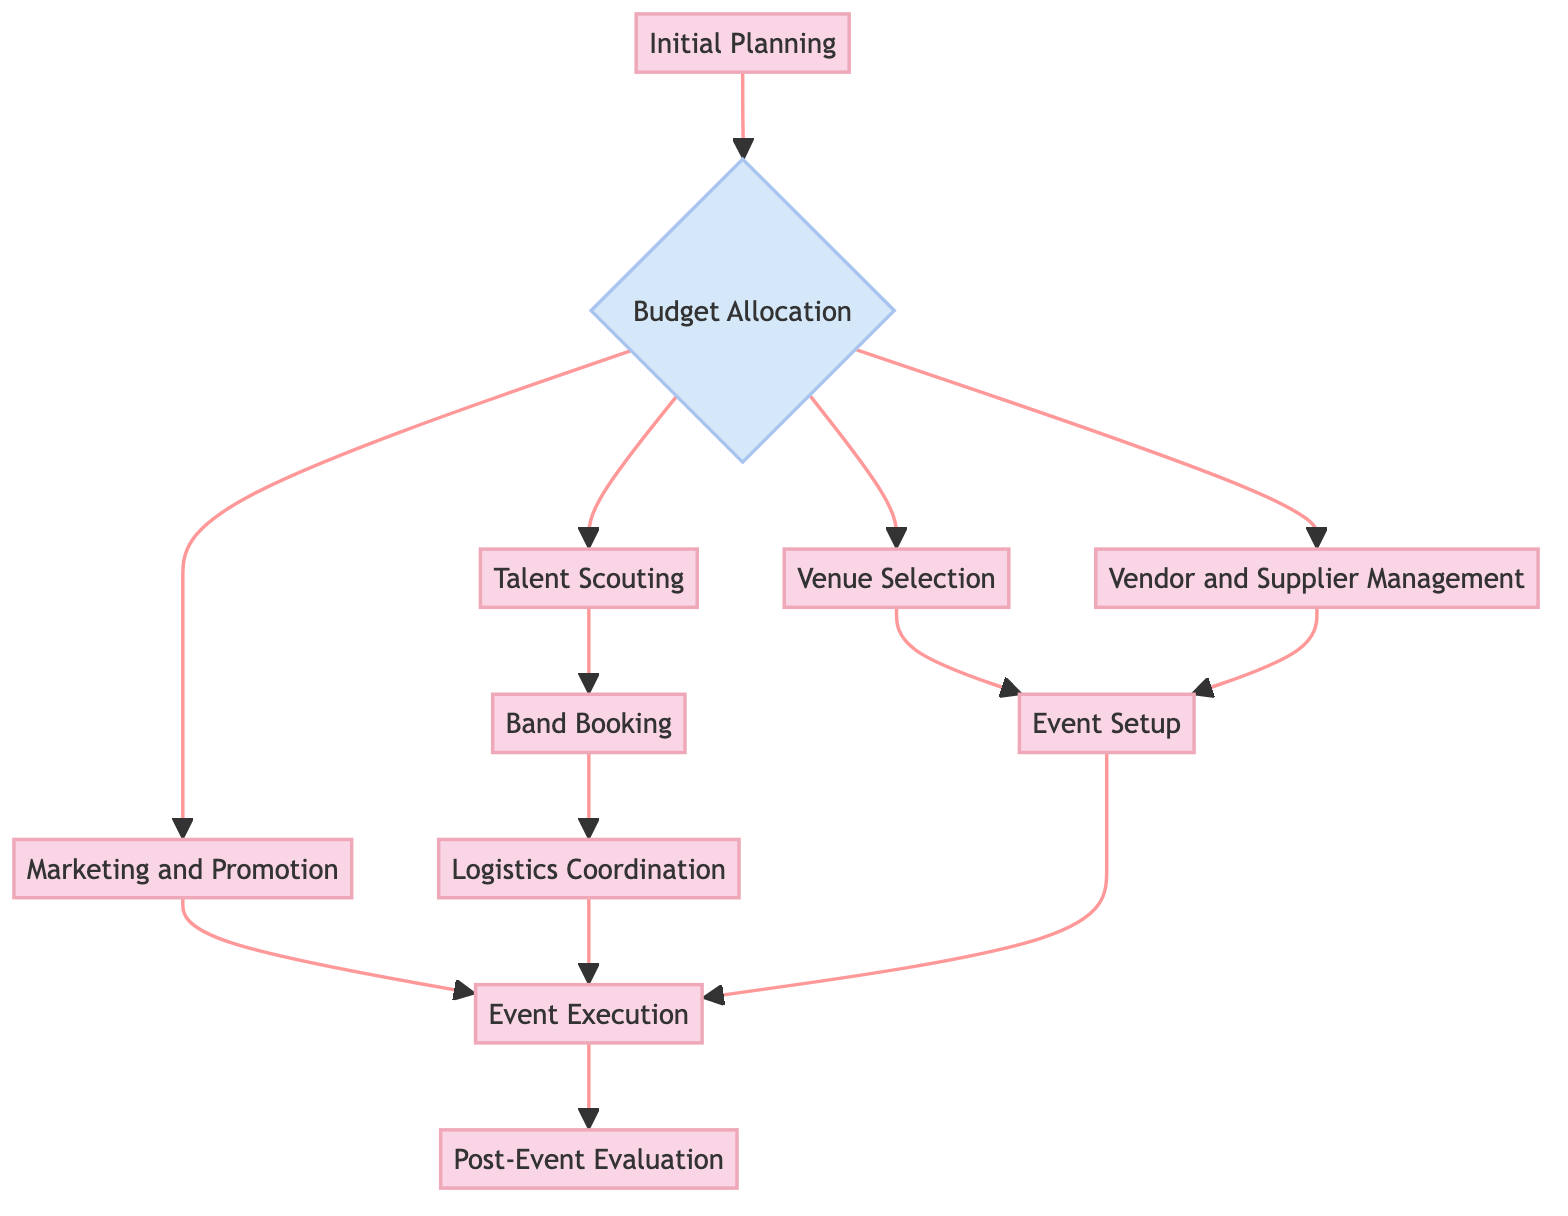What is the first process in the workflow? The diagram indicates that the first process is "Initial Planning." This can be identified as the starting node of the flowchart, as it does not have any incoming arrows and is labeled distinctly.
Answer: Initial Planning How many decision nodes are present in the diagram? By reviewing the diagram, only one node is designated as a decision, indicated by a diamond shape. This corresponds to the "Budget Allocation" node.
Answer: 1 Which process follows the "Budget Allocation" decision? According to the diagram, after the "Budget Allocation" decision node, the next processes can flow out to several nodes, including "Venue Selection," "Talent Scouting," "Marketing and Promotion," and "Vendor and Supplier Management." Among these, the first one in the flow is "Venue Selection."
Answer: Venue Selection Who manages the festival during the event days? From the diagram, "Event Execution" is the process that clearly states it involves managing the festival during the event days. This node is reached following the marketing and logistics coordination steps.
Answer: Event Execution What is the last process in the workflow? The last process in the workflow is "Post-Event Evaluation," as indicated by its position at the end of the flowchart with no outgoing edges.
Answer: Post-Event Evaluation What processes are connected to "Talent Scouting"? The diagram shows that after "Talent Scouting," the next step is "Band Booking," forming a direct connection from one process to the next. This indicates that "Band Booking" is the subsequent action to follow after identifying potential bands.
Answer: Band Booking Which processes lead to "Event Setup"? The processes leading to "Event Setup" are "Venue Selection" and "Vendor and Supplier Management." Both processes provide the necessary preparations for setting up the stages and infrastructure required for the festival.
Answer: Venue Selection and Vendor and Supplier Management What happens after "Event Setup"? Following "Event Setup" in the workflow, the next process is "Event Execution." This transition indicates that after all necessary preparations, the execution of the festival takes place.
Answer: Event Execution 